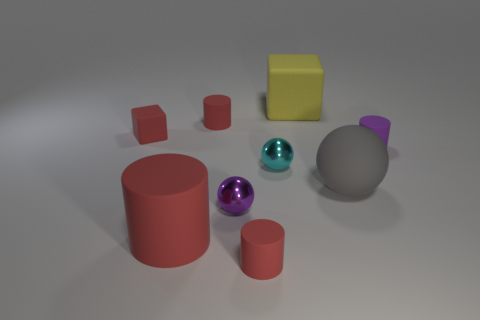Is the large object in front of the rubber ball made of the same material as the cyan thing in front of the red block?
Provide a succinct answer. No. There is a purple thing that is on the right side of the small sphere that is in front of the tiny cyan sphere; how many small balls are left of it?
Make the answer very short. 2. There is a matte block that is left of the purple shiny sphere; is it the same color as the large matte object left of the tiny cyan metal sphere?
Your answer should be compact. Yes. Are there any other things that are the same color as the big block?
Your answer should be very brief. No. There is a tiny metal thing right of the tiny red cylinder that is in front of the big gray ball; what is its color?
Provide a succinct answer. Cyan. Are there any large matte blocks?
Give a very brief answer. Yes. The object that is both to the right of the large yellow thing and to the left of the tiny purple cylinder is what color?
Offer a very short reply. Gray. Is the size of the purple object right of the cyan object the same as the red cylinder behind the gray rubber sphere?
Provide a succinct answer. Yes. What number of other objects are the same size as the gray matte sphere?
Give a very brief answer. 2. There is a tiny rubber cylinder in front of the small purple ball; how many red rubber things are to the left of it?
Provide a succinct answer. 3. 